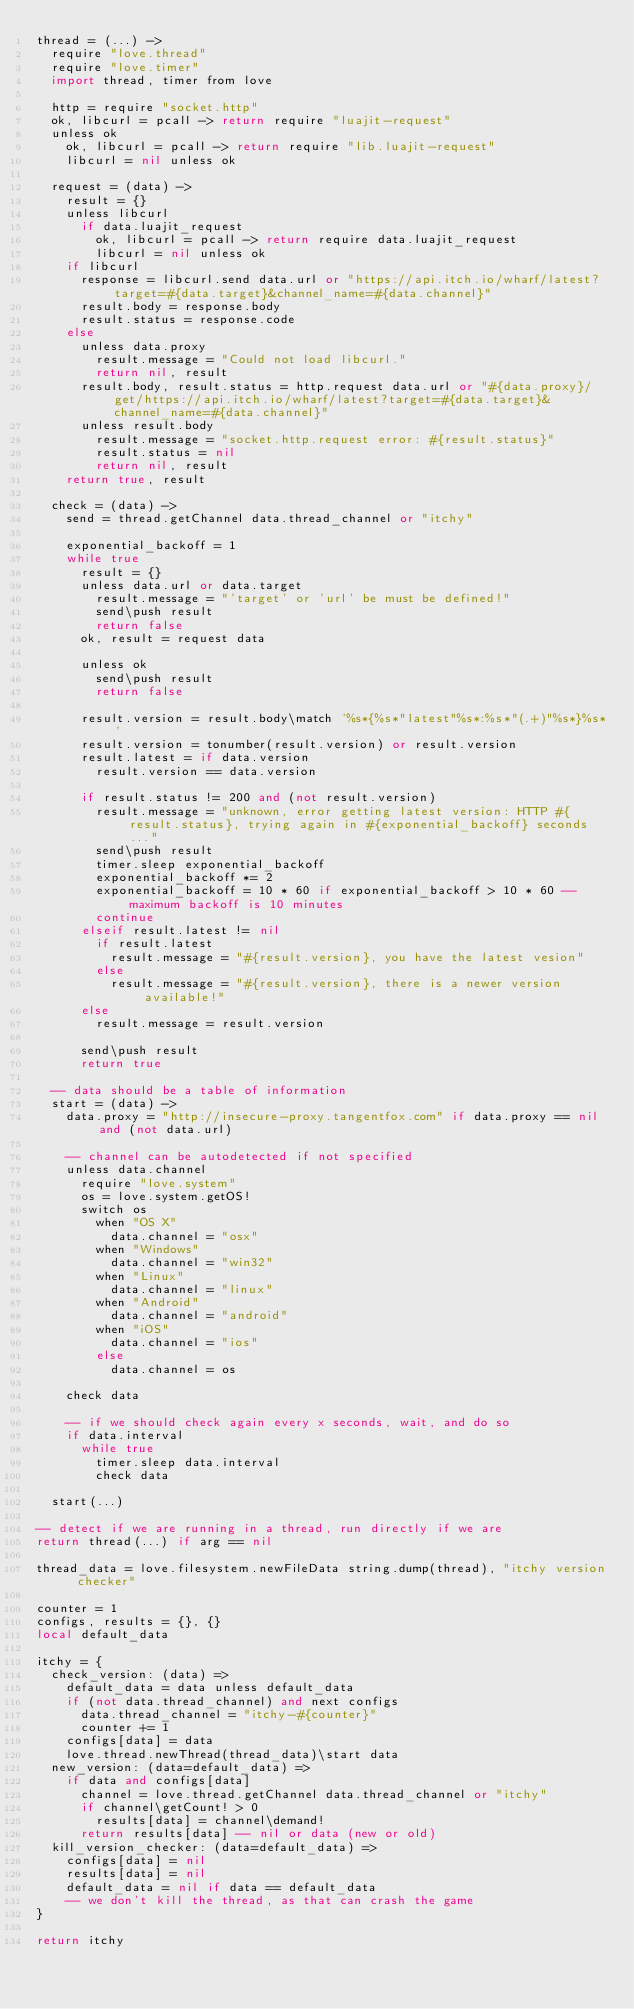<code> <loc_0><loc_0><loc_500><loc_500><_MoonScript_>thread = (...) ->
  require "love.thread"
  require "love.timer"
  import thread, timer from love

  http = require "socket.http"
  ok, libcurl = pcall -> return require "luajit-request"
  unless ok
    ok, libcurl = pcall -> return require "lib.luajit-request"
    libcurl = nil unless ok

  request = (data) ->
    result = {}
    unless libcurl
      if data.luajit_request
        ok, libcurl = pcall -> return require data.luajit_request
        libcurl = nil unless ok
    if libcurl
      response = libcurl.send data.url or "https://api.itch.io/wharf/latest?target=#{data.target}&channel_name=#{data.channel}"
      result.body = response.body
      result.status = response.code
    else
      unless data.proxy
        result.message = "Could not load libcurl."
        return nil, result
      result.body, result.status = http.request data.url or "#{data.proxy}/get/https://api.itch.io/wharf/latest?target=#{data.target}&channel_name=#{data.channel}"
      unless result.body
        result.message = "socket.http.request error: #{result.status}"
        result.status = nil
        return nil, result
    return true, result

  check = (data) ->
    send = thread.getChannel data.thread_channel or "itchy"

    exponential_backoff = 1
    while true
      result = {}
      unless data.url or data.target
        result.message = "'target' or 'url' be must be defined!"
        send\push result
        return false
      ok, result = request data

      unless ok
        send\push result
        return false

      result.version = result.body\match '%s*{%s*"latest"%s*:%s*"(.+)"%s*}%s*'
      result.version = tonumber(result.version) or result.version
      result.latest = if data.version
        result.version == data.version

      if result.status != 200 and (not result.version)
        result.message = "unknown, error getting latest version: HTTP #{result.status}, trying again in #{exponential_backoff} seconds..."
        send\push result
        timer.sleep exponential_backoff
        exponential_backoff *= 2
        exponential_backoff = 10 * 60 if exponential_backoff > 10 * 60 -- maximum backoff is 10 minutes
        continue
      elseif result.latest != nil
        if result.latest
          result.message = "#{result.version}, you have the latest vesion"
        else
          result.message = "#{result.version}, there is a newer version available!"
      else
        result.message = result.version

      send\push result
      return true

  -- data should be a table of information
  start = (data) ->
    data.proxy = "http://insecure-proxy.tangentfox.com" if data.proxy == nil and (not data.url)

    -- channel can be autodetected if not specified
    unless data.channel
      require "love.system"
      os = love.system.getOS!
      switch os
        when "OS X"
          data.channel = "osx"
        when "Windows"
          data.channel = "win32"
        when "Linux"
          data.channel = "linux"
        when "Android"
          data.channel = "android"
        when "iOS"
          data.channel = "ios"
        else
          data.channel = os

    check data

    -- if we should check again every x seconds, wait, and do so
    if data.interval
      while true
        timer.sleep data.interval
        check data

  start(...)

-- detect if we are running in a thread, run directly if we are
return thread(...) if arg == nil

thread_data = love.filesystem.newFileData string.dump(thread), "itchy version checker"

counter = 1
configs, results = {}, {}
local default_data

itchy = {
  check_version: (data) =>
    default_data = data unless default_data
    if (not data.thread_channel) and next configs
      data.thread_channel = "itchy-#{counter}"
      counter += 1
    configs[data] = data
    love.thread.newThread(thread_data)\start data
  new_version: (data=default_data) =>
    if data and configs[data]
      channel = love.thread.getChannel data.thread_channel or "itchy"
      if channel\getCount! > 0
        results[data] = channel\demand!
      return results[data] -- nil or data (new or old)
  kill_version_checker: (data=default_data) =>
    configs[data] = nil
    results[data] = nil
    default_data = nil if data == default_data
    -- we don't kill the thread, as that can crash the game
}

return itchy
</code> 